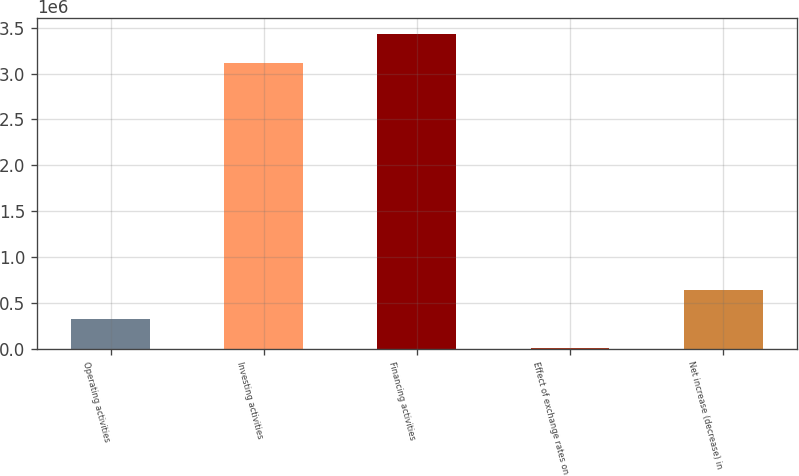<chart> <loc_0><loc_0><loc_500><loc_500><bar_chart><fcel>Operating activities<fcel>Investing activities<fcel>Financing activities<fcel>Effect of exchange rates on<fcel>Net increase (decrease) in<nl><fcel>320933<fcel>3.11134e+06<fcel>3.43037e+06<fcel>1900<fcel>639967<nl></chart> 